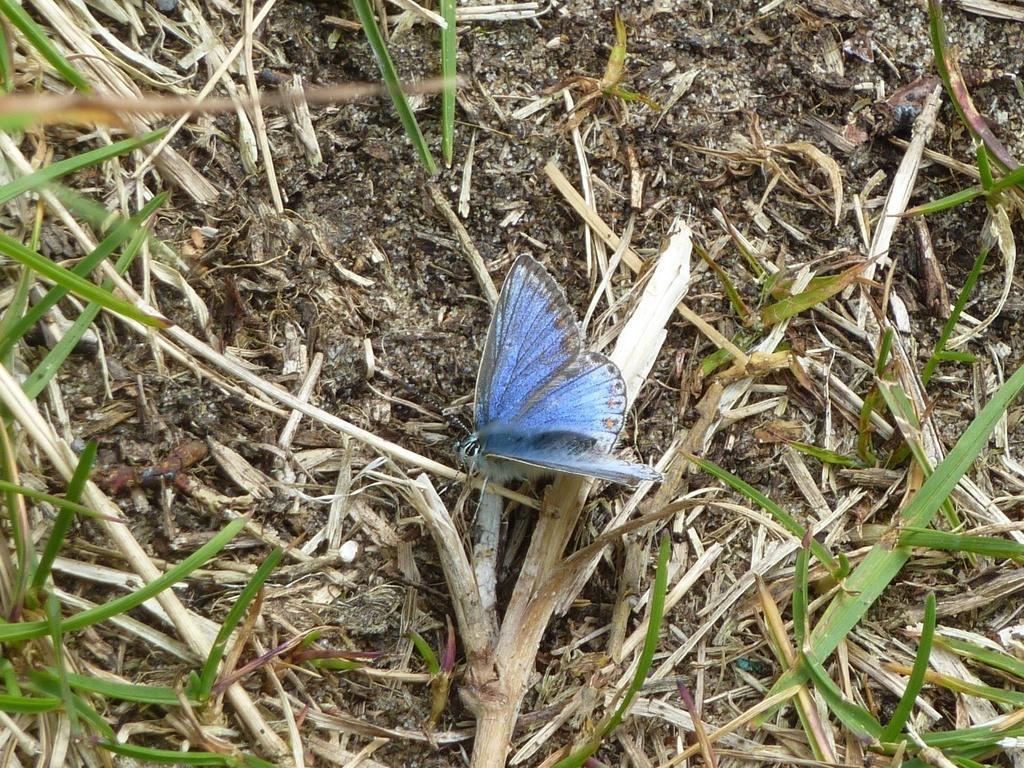Describe this image in one or two sentences. In this image I can see a butterfly. It is blue in color. I can see some grass on the ground. 